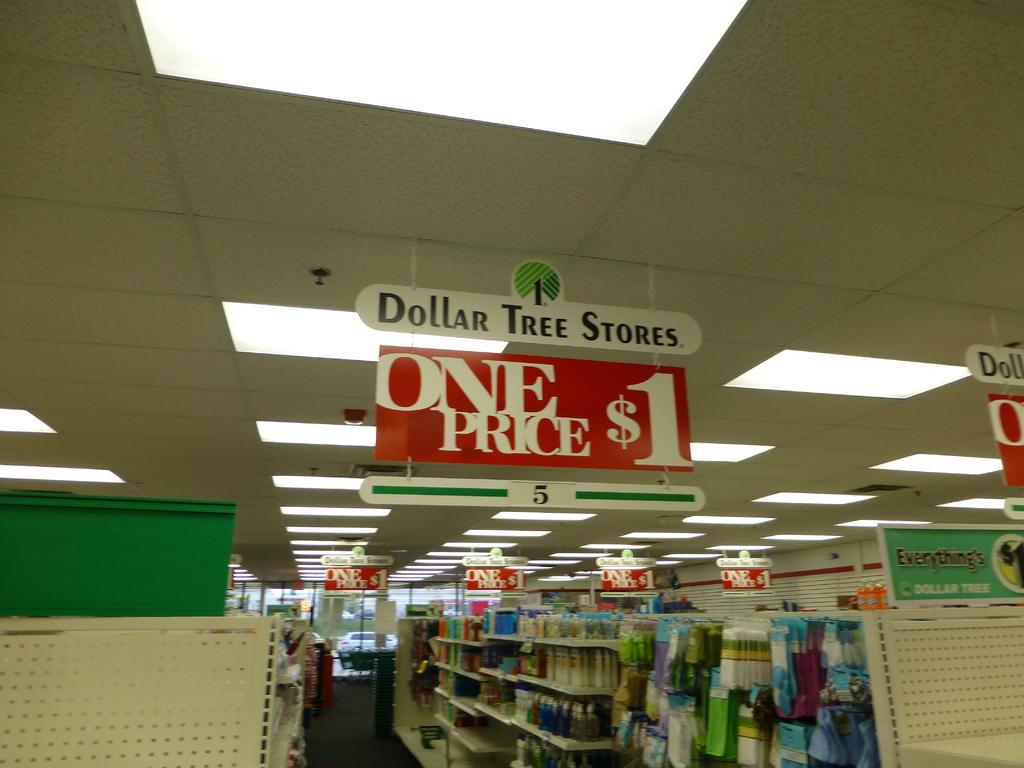<image>
Render a clear and concise summary of the photo. An aisle shot for a Dollar Tree, where everything is a dollar 